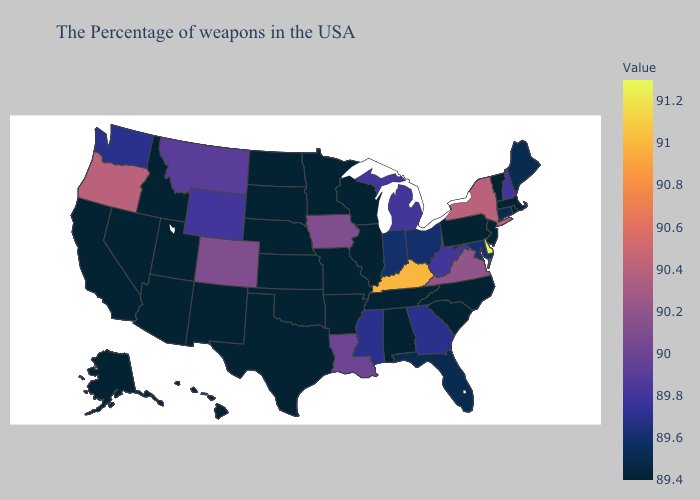Among the states that border Kentucky , does Indiana have the lowest value?
Write a very short answer. No. Does New Hampshire have a lower value than North Dakota?
Concise answer only. No. Among the states that border Mississippi , does Arkansas have the highest value?
Write a very short answer. No. Which states have the lowest value in the USA?
Write a very short answer. Massachusetts, Rhode Island, Vermont, New Jersey, Pennsylvania, North Carolina, South Carolina, Alabama, Tennessee, Wisconsin, Illinois, Missouri, Arkansas, Minnesota, Kansas, Nebraska, Oklahoma, Texas, South Dakota, North Dakota, New Mexico, Utah, Arizona, Idaho, Nevada, California, Alaska, Hawaii. Does Maine have the lowest value in the Northeast?
Concise answer only. No. Does the map have missing data?
Answer briefly. No. 